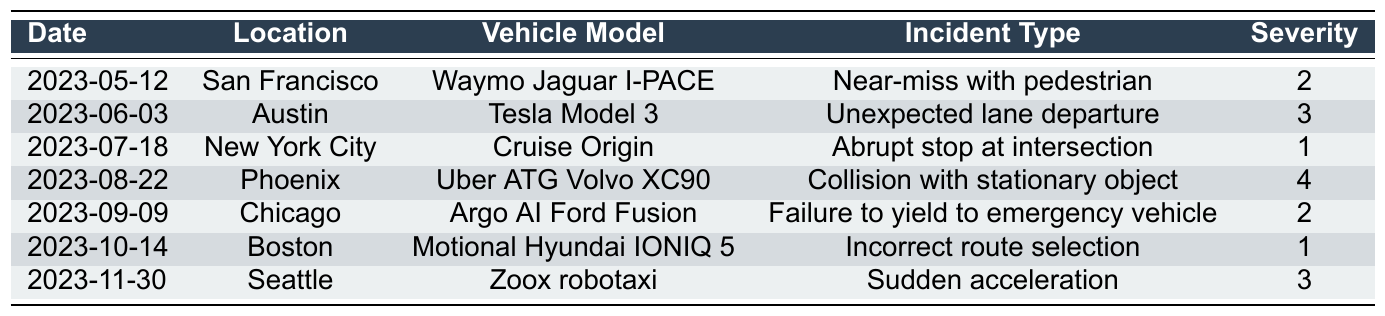What is the incident type for the vehicle model Motional Hyundai IONIQ 5? By examining the table, I can find the row corresponding to the Motional Hyundai IONIQ 5, which shows that the incident type listed for this vehicle is "Incorrect route selection."
Answer: Incorrect route selection Which city had the highest severity incident? Looking at the severity values in the table, the highest severity is 4, which corresponds to the incident that occurred in Phoenix with the Uber ATG Volvo XC90.
Answer: Phoenix How many incidents involved a severity level of 1? Checking each row in the table, I find two incidents with a severity level of 1: the incidents involving the Cruise Origin and the Motional Hyundai IONIQ 5. Therefore, there are two incidents in total.
Answer: 2 Did any incidents occur in snowy weather? By inspecting the weather conditions in the table, I see that there is one incident that occurred in snowy weather, involving the Motional Hyundai IONIQ 5.
Answer: Yes What is the average severity of all incidents recorded in the table? To find the average severity, I first sum the severity values: 2 + 3 + 1 + 4 + 2 + 1 + 3 = 16. There are 7 incidents in total, so the average severity is calculated as 16 / 7, which gives approximately 2.29.
Answer: 2.29 How many incidents involved autonomous vehicles from Waymo? I look through the table and find that there is one incident involving a Waymo vehicle, specifically the Waymo Jaguar I-PACE.
Answer: 1 Which fault component was associated with the incident involving the Uber ATG Volvo XC90? In the row for the Uber ATG Volvo XC90 incident, it is stated that the fault component associated with this incident was the object detection system.
Answer: Object detection system Which weather conditions were reported for incidents with severity levels 2 and 3? By analyzing the table, I find that the incidents with severity level 2 occurred in foggy and overcast conditions, while the incidents with severity level 3 occurred in clear and windy conditions. Therefore, the reported weather conditions are foggy, overcast, clear, and windy.
Answer: Foggy, overcast, clear, windy What is the incident type linked to the highest severity incident that occurred? The highest severity incident has a severity level of 4, which is linked to the incident type "Collision with stationary object" involving the Uber ATG Volvo XC90 in Phoenix.
Answer: Collision with stationary object Which vehicle model is associated with an incident that had a fault component related to the GPS navigation system? By checking the table, I find that the vehicle model Motional Hyundai IONIQ 5 is associated with the incident where the fault component was the GPS navigation system.
Answer: Motional Hyundai IONIQ 5 How many different incident types are listed in the table? I count the unique incident types in the table, which are: "Near-miss with pedestrian," "Unexpected lane departure," "Abrupt stop at intersection," "Collision with stationary object," "Failure to yield to emergency vehicle," "Incorrect route selection," and "Sudden acceleration." This gives a total of 7 different incident types.
Answer: 7 